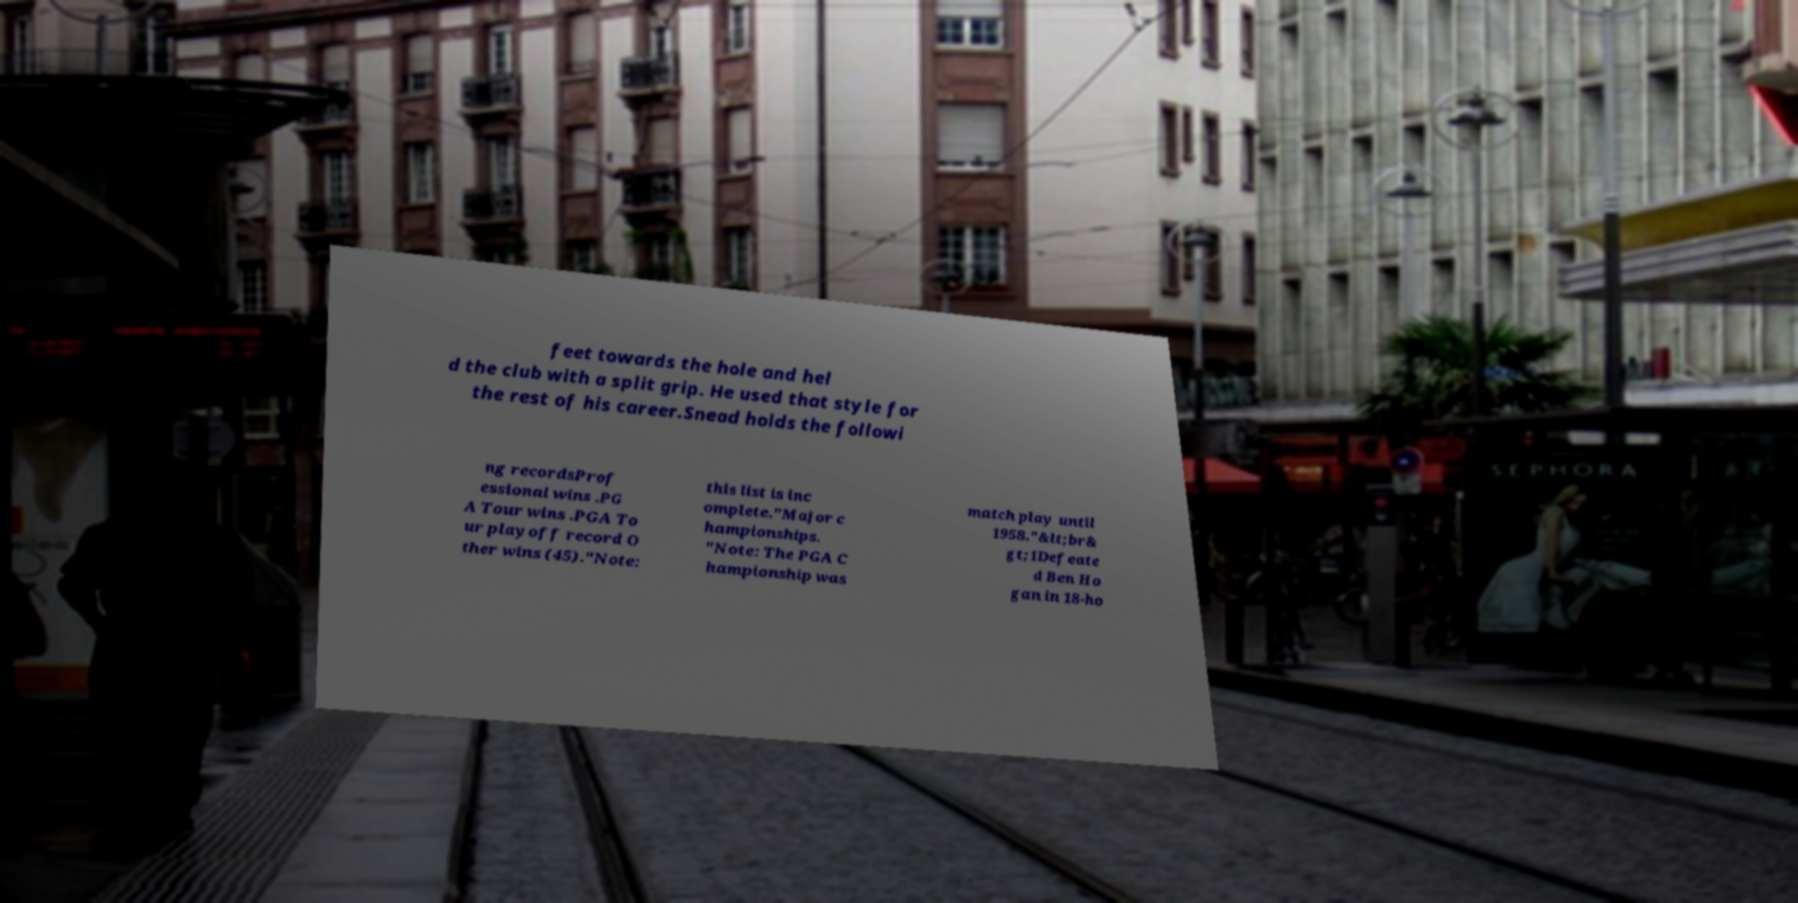I need the written content from this picture converted into text. Can you do that? feet towards the hole and hel d the club with a split grip. He used that style for the rest of his career.Snead holds the followi ng recordsProf essional wins .PG A Tour wins .PGA To ur playoff record O ther wins (45)."Note: this list is inc omplete."Major c hampionships. "Note: The PGA C hampionship was match play until 1958."&lt;br& gt;1Defeate d Ben Ho gan in 18-ho 